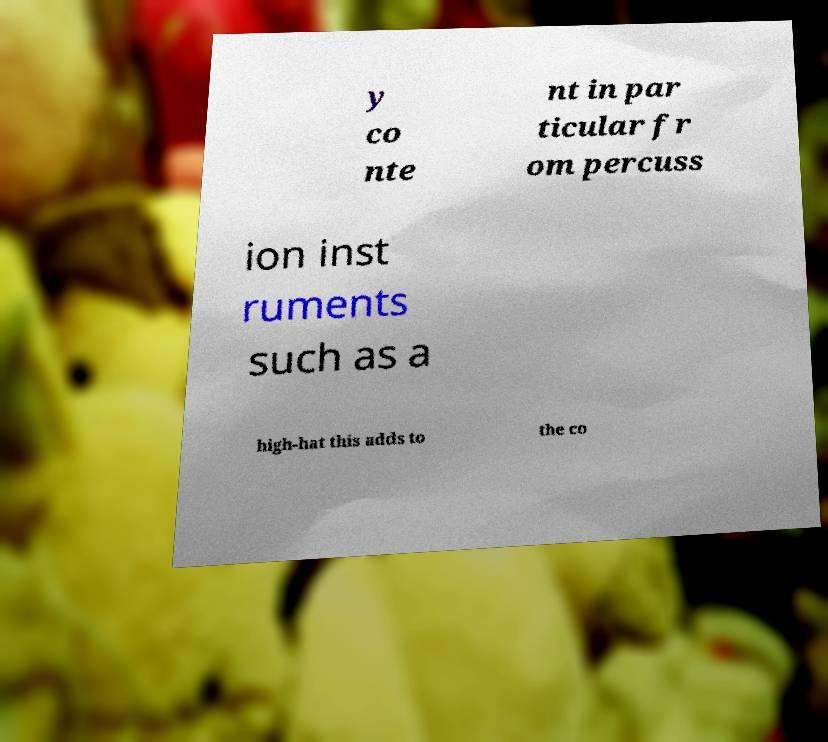Could you extract and type out the text from this image? y co nte nt in par ticular fr om percuss ion inst ruments such as a high-hat this adds to the co 